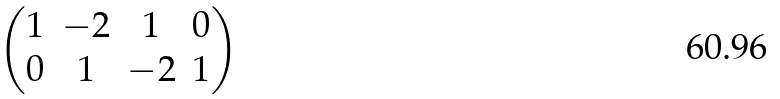<formula> <loc_0><loc_0><loc_500><loc_500>\begin{pmatrix} 1 & - 2 & 1 & 0 \\ 0 & 1 & - 2 & 1 \end{pmatrix}</formula> 